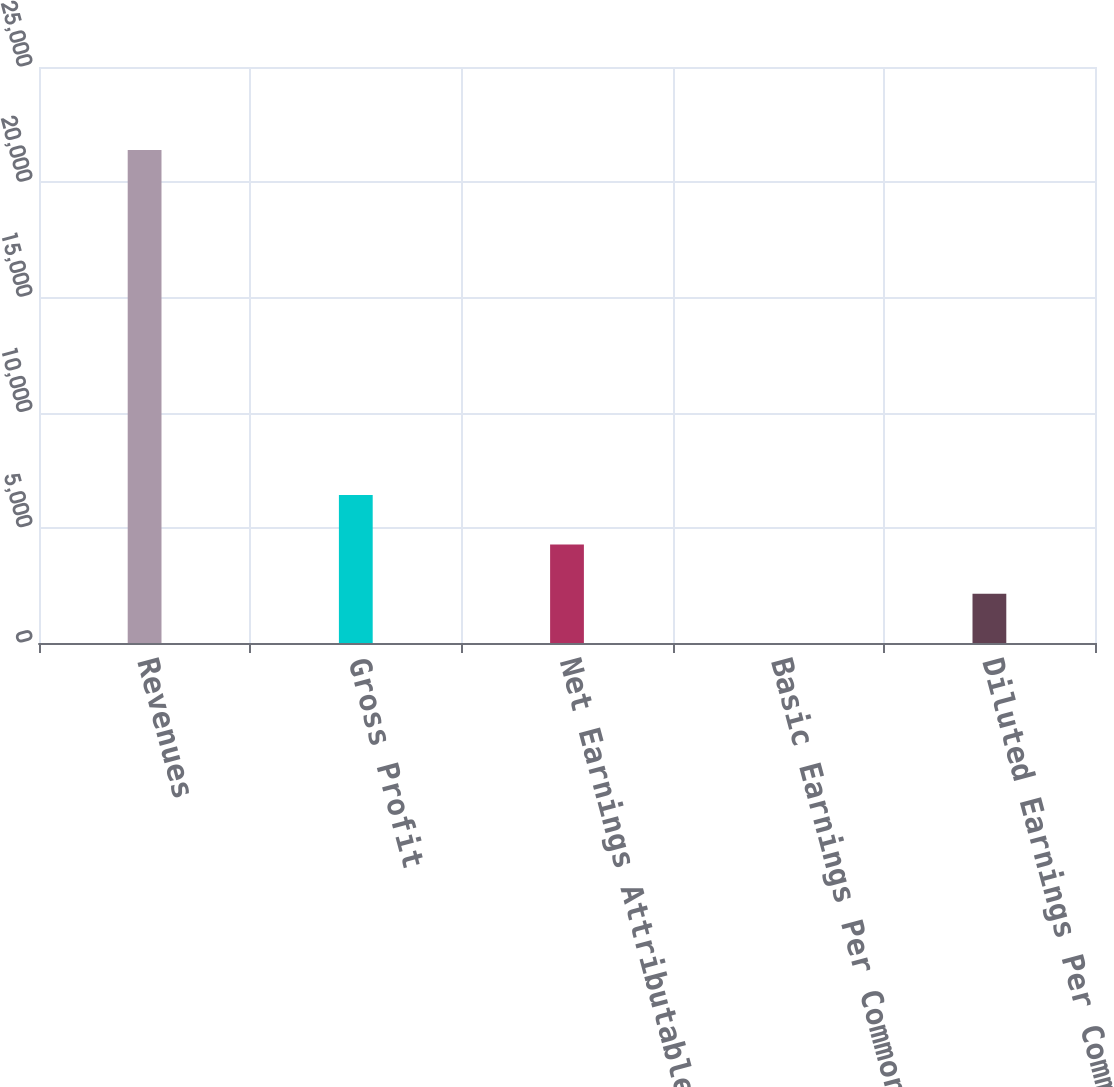Convert chart. <chart><loc_0><loc_0><loc_500><loc_500><bar_chart><fcel>Revenues<fcel>Gross Profit<fcel>Net Earnings Attributable to<fcel>Basic Earnings Per Common<fcel>Diluted Earnings Per Common<nl><fcel>21393<fcel>6418.41<fcel>4279.18<fcel>0.72<fcel>2139.95<nl></chart> 